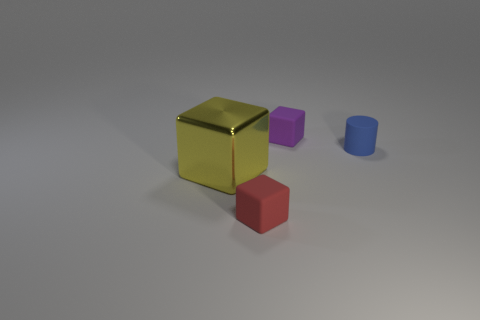Add 3 big spheres. How many objects exist? 7 Subtract all big yellow shiny blocks. How many blocks are left? 2 Subtract all cylinders. How many objects are left? 3 Subtract 0 red cylinders. How many objects are left? 4 Subtract all gray blocks. Subtract all gray cylinders. How many blocks are left? 3 Subtract all gray rubber cubes. Subtract all tiny purple rubber cubes. How many objects are left? 3 Add 4 things. How many things are left? 8 Add 4 yellow blocks. How many yellow blocks exist? 5 